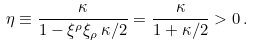<formula> <loc_0><loc_0><loc_500><loc_500>\eta \equiv \frac { \kappa } { 1 - \xi ^ { \rho } \xi _ { \rho } \, \kappa / 2 } = \frac { \kappa } { 1 + \kappa / 2 } > 0 \, .</formula> 